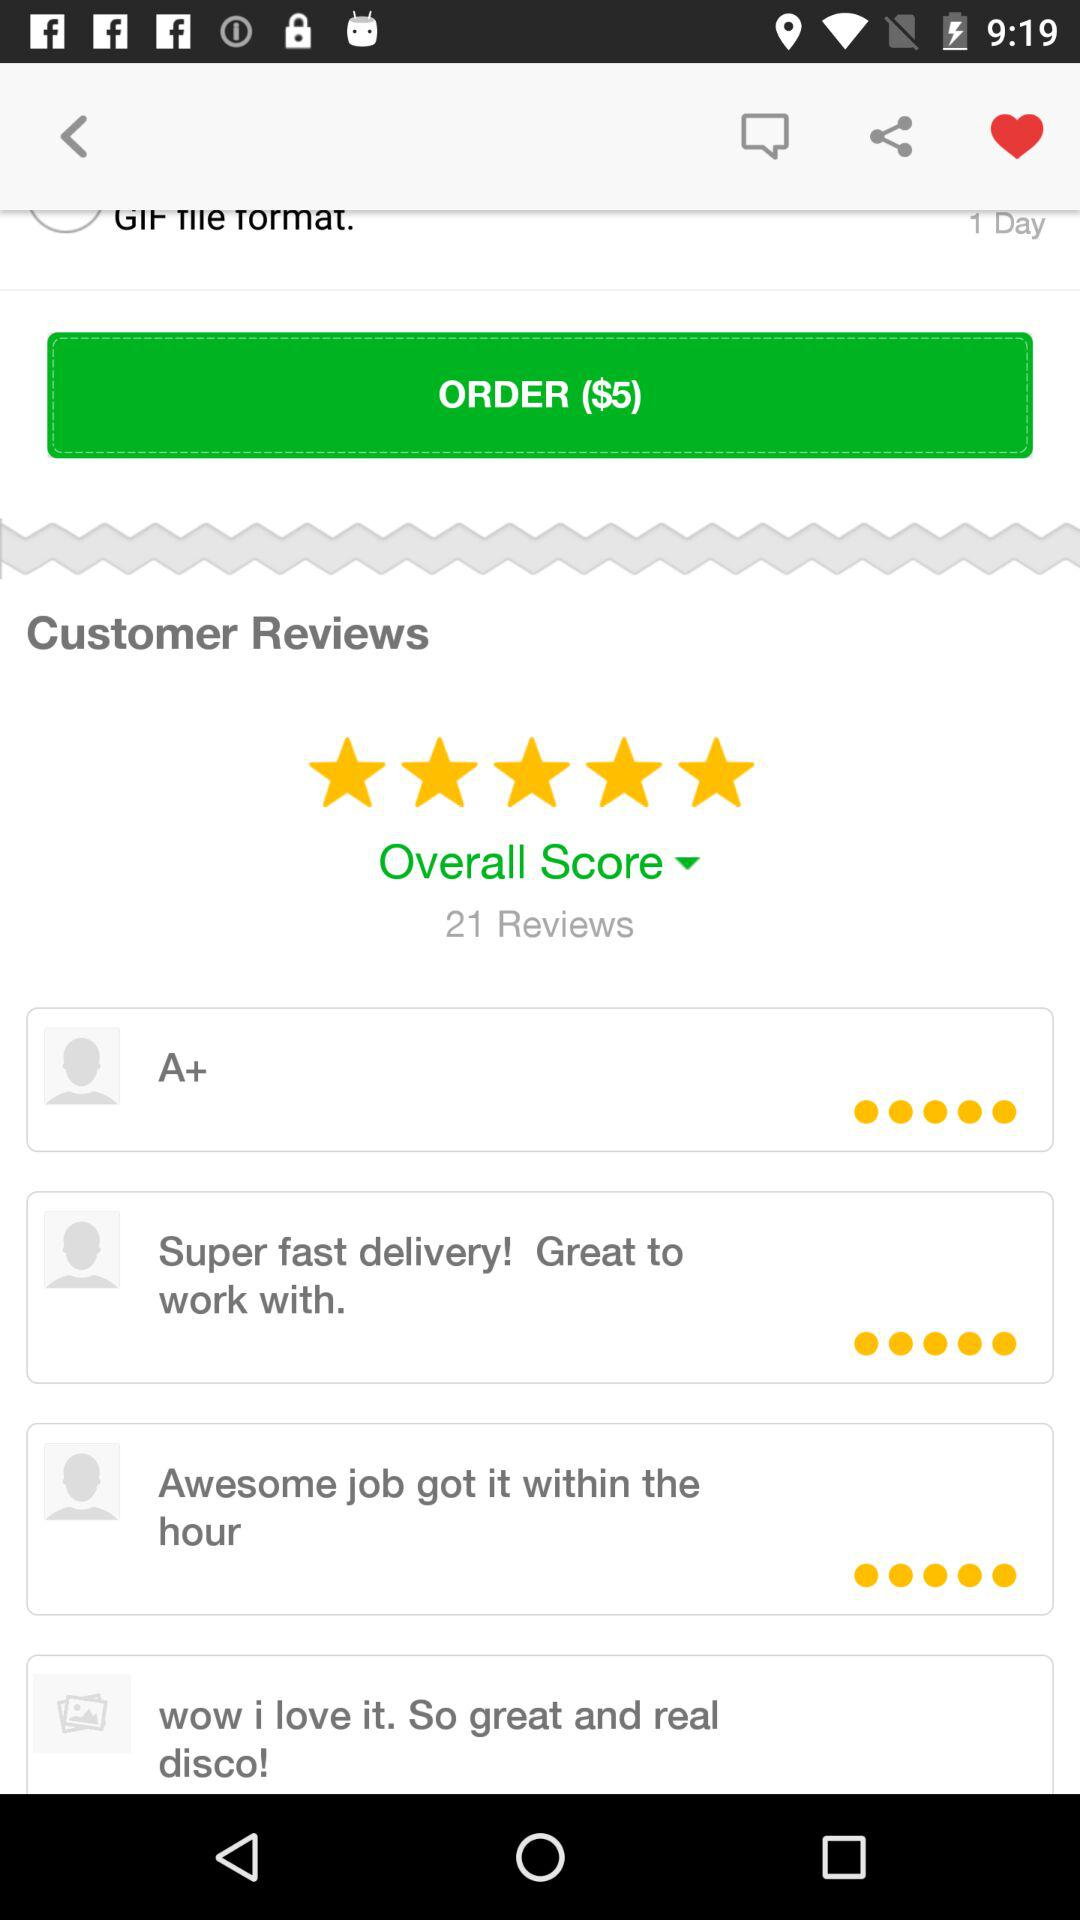What is the price of the order? The price is $5. 